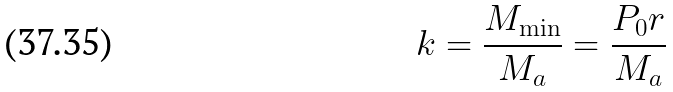Convert formula to latex. <formula><loc_0><loc_0><loc_500><loc_500>k = \frac { M _ { \min } } { M _ { a } } = \frac { P _ { 0 } r } { M _ { a } }</formula> 